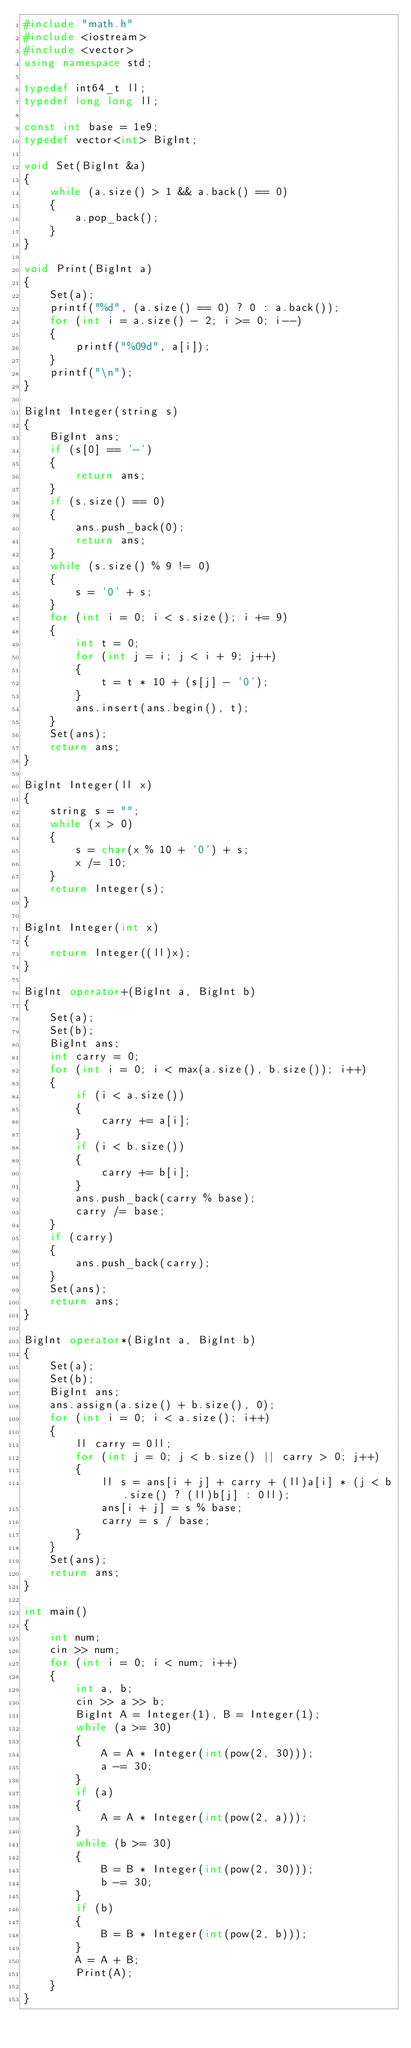Convert code to text. <code><loc_0><loc_0><loc_500><loc_500><_C++_>#include "math.h"
#include <iostream>
#include <vector>
using namespace std;

typedef int64_t ll;
typedef long long ll;

const int base = 1e9;
typedef vector<int> BigInt;

void Set(BigInt &a)
{
    while (a.size() > 1 && a.back() == 0)
    {
        a.pop_back();
    }
}

void Print(BigInt a)
{
    Set(a);
    printf("%d", (a.size() == 0) ? 0 : a.back());
    for (int i = a.size() - 2; i >= 0; i--)
    {
        printf("%09d", a[i]);
    }
    printf("\n");
}

BigInt Integer(string s)
{
    BigInt ans;
    if (s[0] == '-')
    {
        return ans;
    }
    if (s.size() == 0)
    {
        ans.push_back(0);
        return ans;
    }
    while (s.size() % 9 != 0)
    {
        s = '0' + s;
    }
    for (int i = 0; i < s.size(); i += 9)
    {
        int t = 0;
        for (int j = i; j < i + 9; j++)
        {
            t = t * 10 + (s[j] - '0');
        }
        ans.insert(ans.begin(), t);
    }
    Set(ans);
    return ans;
}

BigInt Integer(ll x)
{
    string s = "";
    while (x > 0)
    {
        s = char(x % 10 + '0') + s;
        x /= 10;
    }
    return Integer(s);
}

BigInt Integer(int x)
{
    return Integer((ll)x);
}

BigInt operator+(BigInt a, BigInt b)
{
    Set(a);
    Set(b);
    BigInt ans;
    int carry = 0;
    for (int i = 0; i < max(a.size(), b.size()); i++)
    {
        if (i < a.size())
        {
            carry += a[i];
        }
        if (i < b.size())
        {
            carry += b[i];
        }
        ans.push_back(carry % base);
        carry /= base;
    }
    if (carry)
    {
        ans.push_back(carry);
    }
    Set(ans);
    return ans;
}

BigInt operator*(BigInt a, BigInt b)
{
    Set(a);
    Set(b);
    BigInt ans;
    ans.assign(a.size() + b.size(), 0);
    for (int i = 0; i < a.size(); i++)
    {
        ll carry = 0ll;
        for (int j = 0; j < b.size() || carry > 0; j++)
        {
            ll s = ans[i + j] + carry + (ll)a[i] * (j < b.size() ? (ll)b[j] : 0ll);
            ans[i + j] = s % base;
            carry = s / base;
        }
    }
    Set(ans);
    return ans;
}

int main()
{
    int num;
    cin >> num;
    for (int i = 0; i < num; i++)
    {
        int a, b;
        cin >> a >> b;
        BigInt A = Integer(1), B = Integer(1);
        while (a >= 30)
        {
            A = A * Integer(int(pow(2, 30)));
            a -= 30;
        }
        if (a)
        {
            A = A * Integer(int(pow(2, a)));
        }
        while (b >= 30)
        {
            B = B * Integer(int(pow(2, 30)));
            b -= 30;
        }
        if (b)
        {
            B = B * Integer(int(pow(2, b)));
        }
        A = A + B;
        Print(A);
    }
}</code> 